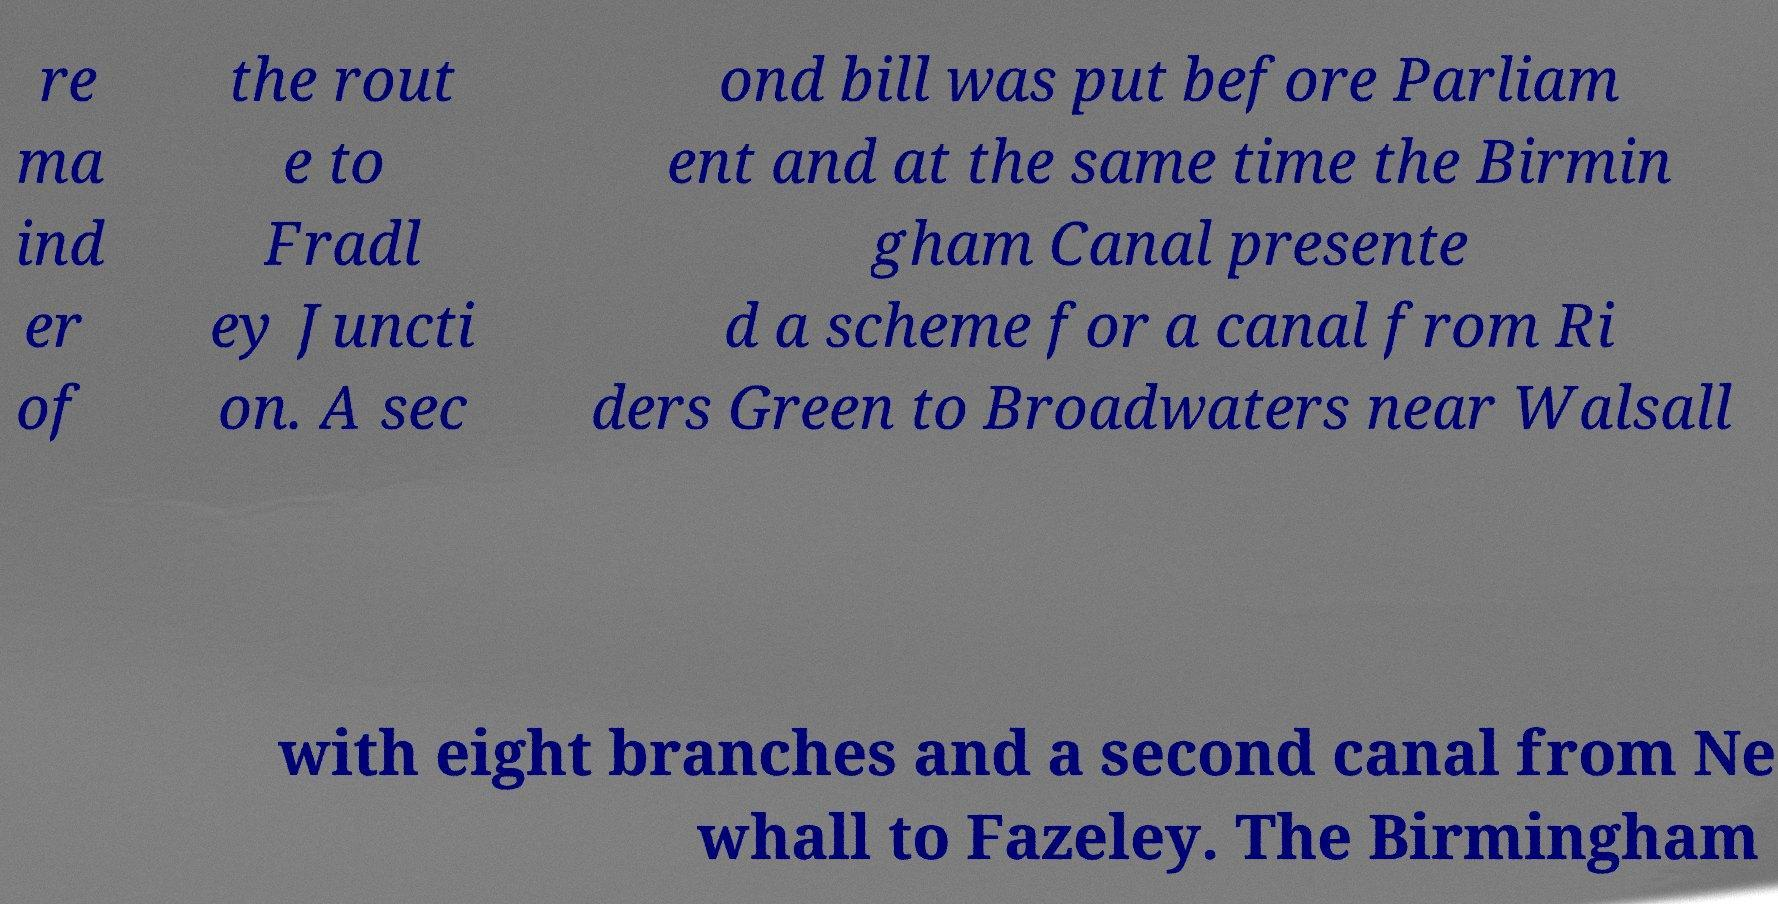There's text embedded in this image that I need extracted. Can you transcribe it verbatim? re ma ind er of the rout e to Fradl ey Juncti on. A sec ond bill was put before Parliam ent and at the same time the Birmin gham Canal presente d a scheme for a canal from Ri ders Green to Broadwaters near Walsall with eight branches and a second canal from Ne whall to Fazeley. The Birmingham 